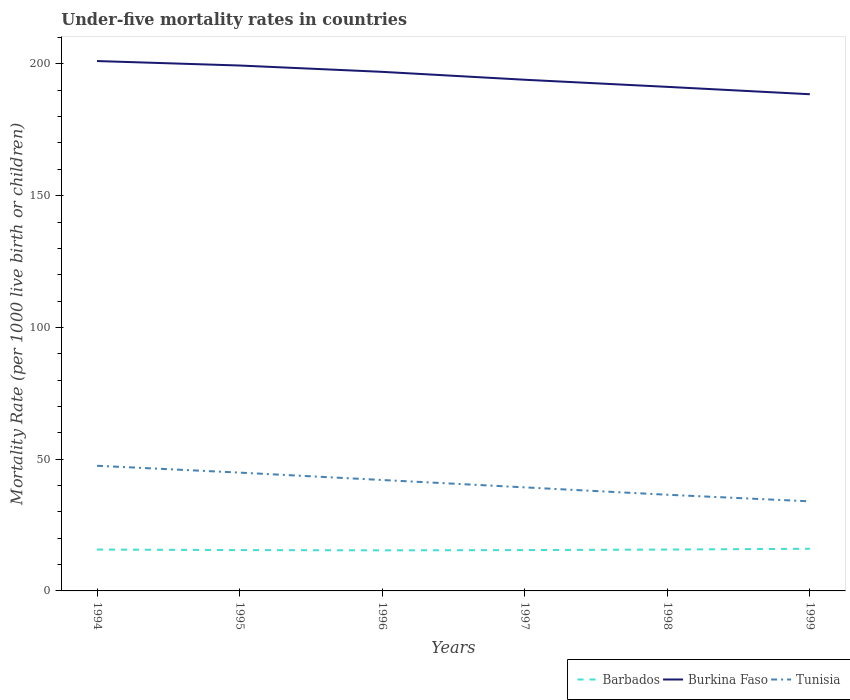How many different coloured lines are there?
Provide a short and direct response. 3. Across all years, what is the maximum under-five mortality rate in Burkina Faso?
Your answer should be very brief. 188.5. What is the total under-five mortality rate in Barbados in the graph?
Your answer should be compact. -0.6. What is the difference between the highest and the second highest under-five mortality rate in Barbados?
Your answer should be very brief. 0.6. What is the difference between the highest and the lowest under-five mortality rate in Barbados?
Offer a terse response. 3. How many lines are there?
Offer a very short reply. 3. What is the difference between two consecutive major ticks on the Y-axis?
Keep it short and to the point. 50. Does the graph contain any zero values?
Your response must be concise. No. Does the graph contain grids?
Keep it short and to the point. No. How many legend labels are there?
Your response must be concise. 3. What is the title of the graph?
Offer a terse response. Under-five mortality rates in countries. Does "East Asia (all income levels)" appear as one of the legend labels in the graph?
Offer a terse response. No. What is the label or title of the Y-axis?
Offer a terse response. Mortality Rate (per 1000 live birth or children). What is the Mortality Rate (per 1000 live birth or children) in Barbados in 1994?
Offer a terse response. 15.7. What is the Mortality Rate (per 1000 live birth or children) of Burkina Faso in 1994?
Provide a short and direct response. 201.1. What is the Mortality Rate (per 1000 live birth or children) in Tunisia in 1994?
Offer a terse response. 47.5. What is the Mortality Rate (per 1000 live birth or children) in Burkina Faso in 1995?
Your response must be concise. 199.4. What is the Mortality Rate (per 1000 live birth or children) in Tunisia in 1995?
Make the answer very short. 44.9. What is the Mortality Rate (per 1000 live birth or children) in Burkina Faso in 1996?
Provide a succinct answer. 197. What is the Mortality Rate (per 1000 live birth or children) in Tunisia in 1996?
Keep it short and to the point. 42.1. What is the Mortality Rate (per 1000 live birth or children) in Barbados in 1997?
Offer a very short reply. 15.5. What is the Mortality Rate (per 1000 live birth or children) in Burkina Faso in 1997?
Give a very brief answer. 194. What is the Mortality Rate (per 1000 live birth or children) in Tunisia in 1997?
Make the answer very short. 39.3. What is the Mortality Rate (per 1000 live birth or children) of Barbados in 1998?
Provide a succinct answer. 15.7. What is the Mortality Rate (per 1000 live birth or children) of Burkina Faso in 1998?
Provide a succinct answer. 191.3. What is the Mortality Rate (per 1000 live birth or children) in Tunisia in 1998?
Your answer should be compact. 36.5. What is the Mortality Rate (per 1000 live birth or children) in Barbados in 1999?
Give a very brief answer. 16. What is the Mortality Rate (per 1000 live birth or children) in Burkina Faso in 1999?
Ensure brevity in your answer.  188.5. Across all years, what is the maximum Mortality Rate (per 1000 live birth or children) of Barbados?
Offer a terse response. 16. Across all years, what is the maximum Mortality Rate (per 1000 live birth or children) of Burkina Faso?
Your answer should be compact. 201.1. Across all years, what is the maximum Mortality Rate (per 1000 live birth or children) in Tunisia?
Give a very brief answer. 47.5. Across all years, what is the minimum Mortality Rate (per 1000 live birth or children) in Burkina Faso?
Provide a succinct answer. 188.5. Across all years, what is the minimum Mortality Rate (per 1000 live birth or children) in Tunisia?
Offer a very short reply. 34. What is the total Mortality Rate (per 1000 live birth or children) of Barbados in the graph?
Your answer should be very brief. 93.8. What is the total Mortality Rate (per 1000 live birth or children) in Burkina Faso in the graph?
Offer a terse response. 1171.3. What is the total Mortality Rate (per 1000 live birth or children) of Tunisia in the graph?
Offer a terse response. 244.3. What is the difference between the Mortality Rate (per 1000 live birth or children) of Burkina Faso in 1994 and that in 1995?
Your response must be concise. 1.7. What is the difference between the Mortality Rate (per 1000 live birth or children) of Tunisia in 1994 and that in 1995?
Your response must be concise. 2.6. What is the difference between the Mortality Rate (per 1000 live birth or children) of Burkina Faso in 1994 and that in 1996?
Ensure brevity in your answer.  4.1. What is the difference between the Mortality Rate (per 1000 live birth or children) of Burkina Faso in 1994 and that in 1997?
Your answer should be compact. 7.1. What is the difference between the Mortality Rate (per 1000 live birth or children) of Tunisia in 1994 and that in 1997?
Your answer should be compact. 8.2. What is the difference between the Mortality Rate (per 1000 live birth or children) of Barbados in 1994 and that in 1998?
Keep it short and to the point. 0. What is the difference between the Mortality Rate (per 1000 live birth or children) of Burkina Faso in 1994 and that in 1998?
Your answer should be very brief. 9.8. What is the difference between the Mortality Rate (per 1000 live birth or children) in Burkina Faso in 1994 and that in 1999?
Offer a very short reply. 12.6. What is the difference between the Mortality Rate (per 1000 live birth or children) of Barbados in 1995 and that in 1996?
Your answer should be very brief. 0.1. What is the difference between the Mortality Rate (per 1000 live birth or children) of Tunisia in 1995 and that in 1996?
Offer a very short reply. 2.8. What is the difference between the Mortality Rate (per 1000 live birth or children) in Burkina Faso in 1995 and that in 1997?
Offer a terse response. 5.4. What is the difference between the Mortality Rate (per 1000 live birth or children) in Tunisia in 1995 and that in 1997?
Offer a terse response. 5.6. What is the difference between the Mortality Rate (per 1000 live birth or children) of Barbados in 1995 and that in 1998?
Keep it short and to the point. -0.2. What is the difference between the Mortality Rate (per 1000 live birth or children) of Burkina Faso in 1995 and that in 1999?
Make the answer very short. 10.9. What is the difference between the Mortality Rate (per 1000 live birth or children) in Tunisia in 1996 and that in 1997?
Offer a very short reply. 2.8. What is the difference between the Mortality Rate (per 1000 live birth or children) in Burkina Faso in 1996 and that in 1998?
Offer a terse response. 5.7. What is the difference between the Mortality Rate (per 1000 live birth or children) in Barbados in 1996 and that in 1999?
Make the answer very short. -0.6. What is the difference between the Mortality Rate (per 1000 live birth or children) in Tunisia in 1996 and that in 1999?
Your answer should be compact. 8.1. What is the difference between the Mortality Rate (per 1000 live birth or children) of Barbados in 1997 and that in 1998?
Your response must be concise. -0.2. What is the difference between the Mortality Rate (per 1000 live birth or children) in Burkina Faso in 1997 and that in 1998?
Offer a very short reply. 2.7. What is the difference between the Mortality Rate (per 1000 live birth or children) in Barbados in 1997 and that in 1999?
Offer a very short reply. -0.5. What is the difference between the Mortality Rate (per 1000 live birth or children) of Tunisia in 1997 and that in 1999?
Your answer should be compact. 5.3. What is the difference between the Mortality Rate (per 1000 live birth or children) of Barbados in 1994 and the Mortality Rate (per 1000 live birth or children) of Burkina Faso in 1995?
Provide a short and direct response. -183.7. What is the difference between the Mortality Rate (per 1000 live birth or children) in Barbados in 1994 and the Mortality Rate (per 1000 live birth or children) in Tunisia in 1995?
Keep it short and to the point. -29.2. What is the difference between the Mortality Rate (per 1000 live birth or children) of Burkina Faso in 1994 and the Mortality Rate (per 1000 live birth or children) of Tunisia in 1995?
Make the answer very short. 156.2. What is the difference between the Mortality Rate (per 1000 live birth or children) of Barbados in 1994 and the Mortality Rate (per 1000 live birth or children) of Burkina Faso in 1996?
Offer a terse response. -181.3. What is the difference between the Mortality Rate (per 1000 live birth or children) in Barbados in 1994 and the Mortality Rate (per 1000 live birth or children) in Tunisia in 1996?
Provide a short and direct response. -26.4. What is the difference between the Mortality Rate (per 1000 live birth or children) in Burkina Faso in 1994 and the Mortality Rate (per 1000 live birth or children) in Tunisia in 1996?
Provide a succinct answer. 159. What is the difference between the Mortality Rate (per 1000 live birth or children) in Barbados in 1994 and the Mortality Rate (per 1000 live birth or children) in Burkina Faso in 1997?
Offer a very short reply. -178.3. What is the difference between the Mortality Rate (per 1000 live birth or children) in Barbados in 1994 and the Mortality Rate (per 1000 live birth or children) in Tunisia in 1997?
Your answer should be very brief. -23.6. What is the difference between the Mortality Rate (per 1000 live birth or children) of Burkina Faso in 1994 and the Mortality Rate (per 1000 live birth or children) of Tunisia in 1997?
Make the answer very short. 161.8. What is the difference between the Mortality Rate (per 1000 live birth or children) of Barbados in 1994 and the Mortality Rate (per 1000 live birth or children) of Burkina Faso in 1998?
Offer a terse response. -175.6. What is the difference between the Mortality Rate (per 1000 live birth or children) in Barbados in 1994 and the Mortality Rate (per 1000 live birth or children) in Tunisia in 1998?
Your response must be concise. -20.8. What is the difference between the Mortality Rate (per 1000 live birth or children) in Burkina Faso in 1994 and the Mortality Rate (per 1000 live birth or children) in Tunisia in 1998?
Your response must be concise. 164.6. What is the difference between the Mortality Rate (per 1000 live birth or children) of Barbados in 1994 and the Mortality Rate (per 1000 live birth or children) of Burkina Faso in 1999?
Give a very brief answer. -172.8. What is the difference between the Mortality Rate (per 1000 live birth or children) of Barbados in 1994 and the Mortality Rate (per 1000 live birth or children) of Tunisia in 1999?
Your response must be concise. -18.3. What is the difference between the Mortality Rate (per 1000 live birth or children) of Burkina Faso in 1994 and the Mortality Rate (per 1000 live birth or children) of Tunisia in 1999?
Provide a short and direct response. 167.1. What is the difference between the Mortality Rate (per 1000 live birth or children) of Barbados in 1995 and the Mortality Rate (per 1000 live birth or children) of Burkina Faso in 1996?
Your response must be concise. -181.5. What is the difference between the Mortality Rate (per 1000 live birth or children) of Barbados in 1995 and the Mortality Rate (per 1000 live birth or children) of Tunisia in 1996?
Make the answer very short. -26.6. What is the difference between the Mortality Rate (per 1000 live birth or children) of Burkina Faso in 1995 and the Mortality Rate (per 1000 live birth or children) of Tunisia in 1996?
Your answer should be very brief. 157.3. What is the difference between the Mortality Rate (per 1000 live birth or children) of Barbados in 1995 and the Mortality Rate (per 1000 live birth or children) of Burkina Faso in 1997?
Your answer should be compact. -178.5. What is the difference between the Mortality Rate (per 1000 live birth or children) in Barbados in 1995 and the Mortality Rate (per 1000 live birth or children) in Tunisia in 1997?
Keep it short and to the point. -23.8. What is the difference between the Mortality Rate (per 1000 live birth or children) in Burkina Faso in 1995 and the Mortality Rate (per 1000 live birth or children) in Tunisia in 1997?
Offer a terse response. 160.1. What is the difference between the Mortality Rate (per 1000 live birth or children) of Barbados in 1995 and the Mortality Rate (per 1000 live birth or children) of Burkina Faso in 1998?
Your answer should be very brief. -175.8. What is the difference between the Mortality Rate (per 1000 live birth or children) of Barbados in 1995 and the Mortality Rate (per 1000 live birth or children) of Tunisia in 1998?
Offer a very short reply. -21. What is the difference between the Mortality Rate (per 1000 live birth or children) in Burkina Faso in 1995 and the Mortality Rate (per 1000 live birth or children) in Tunisia in 1998?
Your answer should be compact. 162.9. What is the difference between the Mortality Rate (per 1000 live birth or children) in Barbados in 1995 and the Mortality Rate (per 1000 live birth or children) in Burkina Faso in 1999?
Ensure brevity in your answer.  -173. What is the difference between the Mortality Rate (per 1000 live birth or children) of Barbados in 1995 and the Mortality Rate (per 1000 live birth or children) of Tunisia in 1999?
Give a very brief answer. -18.5. What is the difference between the Mortality Rate (per 1000 live birth or children) in Burkina Faso in 1995 and the Mortality Rate (per 1000 live birth or children) in Tunisia in 1999?
Your answer should be compact. 165.4. What is the difference between the Mortality Rate (per 1000 live birth or children) of Barbados in 1996 and the Mortality Rate (per 1000 live birth or children) of Burkina Faso in 1997?
Your response must be concise. -178.6. What is the difference between the Mortality Rate (per 1000 live birth or children) of Barbados in 1996 and the Mortality Rate (per 1000 live birth or children) of Tunisia in 1997?
Offer a very short reply. -23.9. What is the difference between the Mortality Rate (per 1000 live birth or children) in Burkina Faso in 1996 and the Mortality Rate (per 1000 live birth or children) in Tunisia in 1997?
Make the answer very short. 157.7. What is the difference between the Mortality Rate (per 1000 live birth or children) in Barbados in 1996 and the Mortality Rate (per 1000 live birth or children) in Burkina Faso in 1998?
Offer a terse response. -175.9. What is the difference between the Mortality Rate (per 1000 live birth or children) of Barbados in 1996 and the Mortality Rate (per 1000 live birth or children) of Tunisia in 1998?
Your answer should be compact. -21.1. What is the difference between the Mortality Rate (per 1000 live birth or children) in Burkina Faso in 1996 and the Mortality Rate (per 1000 live birth or children) in Tunisia in 1998?
Make the answer very short. 160.5. What is the difference between the Mortality Rate (per 1000 live birth or children) of Barbados in 1996 and the Mortality Rate (per 1000 live birth or children) of Burkina Faso in 1999?
Your response must be concise. -173.1. What is the difference between the Mortality Rate (per 1000 live birth or children) in Barbados in 1996 and the Mortality Rate (per 1000 live birth or children) in Tunisia in 1999?
Provide a succinct answer. -18.6. What is the difference between the Mortality Rate (per 1000 live birth or children) in Burkina Faso in 1996 and the Mortality Rate (per 1000 live birth or children) in Tunisia in 1999?
Keep it short and to the point. 163. What is the difference between the Mortality Rate (per 1000 live birth or children) in Barbados in 1997 and the Mortality Rate (per 1000 live birth or children) in Burkina Faso in 1998?
Give a very brief answer. -175.8. What is the difference between the Mortality Rate (per 1000 live birth or children) of Burkina Faso in 1997 and the Mortality Rate (per 1000 live birth or children) of Tunisia in 1998?
Ensure brevity in your answer.  157.5. What is the difference between the Mortality Rate (per 1000 live birth or children) of Barbados in 1997 and the Mortality Rate (per 1000 live birth or children) of Burkina Faso in 1999?
Your response must be concise. -173. What is the difference between the Mortality Rate (per 1000 live birth or children) in Barbados in 1997 and the Mortality Rate (per 1000 live birth or children) in Tunisia in 1999?
Your response must be concise. -18.5. What is the difference between the Mortality Rate (per 1000 live birth or children) of Burkina Faso in 1997 and the Mortality Rate (per 1000 live birth or children) of Tunisia in 1999?
Ensure brevity in your answer.  160. What is the difference between the Mortality Rate (per 1000 live birth or children) of Barbados in 1998 and the Mortality Rate (per 1000 live birth or children) of Burkina Faso in 1999?
Offer a terse response. -172.8. What is the difference between the Mortality Rate (per 1000 live birth or children) in Barbados in 1998 and the Mortality Rate (per 1000 live birth or children) in Tunisia in 1999?
Your answer should be very brief. -18.3. What is the difference between the Mortality Rate (per 1000 live birth or children) of Burkina Faso in 1998 and the Mortality Rate (per 1000 live birth or children) of Tunisia in 1999?
Offer a very short reply. 157.3. What is the average Mortality Rate (per 1000 live birth or children) in Barbados per year?
Your answer should be compact. 15.63. What is the average Mortality Rate (per 1000 live birth or children) of Burkina Faso per year?
Make the answer very short. 195.22. What is the average Mortality Rate (per 1000 live birth or children) of Tunisia per year?
Keep it short and to the point. 40.72. In the year 1994, what is the difference between the Mortality Rate (per 1000 live birth or children) in Barbados and Mortality Rate (per 1000 live birth or children) in Burkina Faso?
Keep it short and to the point. -185.4. In the year 1994, what is the difference between the Mortality Rate (per 1000 live birth or children) of Barbados and Mortality Rate (per 1000 live birth or children) of Tunisia?
Your answer should be very brief. -31.8. In the year 1994, what is the difference between the Mortality Rate (per 1000 live birth or children) in Burkina Faso and Mortality Rate (per 1000 live birth or children) in Tunisia?
Offer a terse response. 153.6. In the year 1995, what is the difference between the Mortality Rate (per 1000 live birth or children) of Barbados and Mortality Rate (per 1000 live birth or children) of Burkina Faso?
Provide a short and direct response. -183.9. In the year 1995, what is the difference between the Mortality Rate (per 1000 live birth or children) of Barbados and Mortality Rate (per 1000 live birth or children) of Tunisia?
Your answer should be compact. -29.4. In the year 1995, what is the difference between the Mortality Rate (per 1000 live birth or children) in Burkina Faso and Mortality Rate (per 1000 live birth or children) in Tunisia?
Provide a short and direct response. 154.5. In the year 1996, what is the difference between the Mortality Rate (per 1000 live birth or children) in Barbados and Mortality Rate (per 1000 live birth or children) in Burkina Faso?
Give a very brief answer. -181.6. In the year 1996, what is the difference between the Mortality Rate (per 1000 live birth or children) in Barbados and Mortality Rate (per 1000 live birth or children) in Tunisia?
Make the answer very short. -26.7. In the year 1996, what is the difference between the Mortality Rate (per 1000 live birth or children) in Burkina Faso and Mortality Rate (per 1000 live birth or children) in Tunisia?
Ensure brevity in your answer.  154.9. In the year 1997, what is the difference between the Mortality Rate (per 1000 live birth or children) in Barbados and Mortality Rate (per 1000 live birth or children) in Burkina Faso?
Make the answer very short. -178.5. In the year 1997, what is the difference between the Mortality Rate (per 1000 live birth or children) of Barbados and Mortality Rate (per 1000 live birth or children) of Tunisia?
Give a very brief answer. -23.8. In the year 1997, what is the difference between the Mortality Rate (per 1000 live birth or children) in Burkina Faso and Mortality Rate (per 1000 live birth or children) in Tunisia?
Your answer should be very brief. 154.7. In the year 1998, what is the difference between the Mortality Rate (per 1000 live birth or children) in Barbados and Mortality Rate (per 1000 live birth or children) in Burkina Faso?
Your answer should be compact. -175.6. In the year 1998, what is the difference between the Mortality Rate (per 1000 live birth or children) of Barbados and Mortality Rate (per 1000 live birth or children) of Tunisia?
Offer a very short reply. -20.8. In the year 1998, what is the difference between the Mortality Rate (per 1000 live birth or children) of Burkina Faso and Mortality Rate (per 1000 live birth or children) of Tunisia?
Offer a terse response. 154.8. In the year 1999, what is the difference between the Mortality Rate (per 1000 live birth or children) of Barbados and Mortality Rate (per 1000 live birth or children) of Burkina Faso?
Your answer should be compact. -172.5. In the year 1999, what is the difference between the Mortality Rate (per 1000 live birth or children) of Barbados and Mortality Rate (per 1000 live birth or children) of Tunisia?
Provide a succinct answer. -18. In the year 1999, what is the difference between the Mortality Rate (per 1000 live birth or children) of Burkina Faso and Mortality Rate (per 1000 live birth or children) of Tunisia?
Keep it short and to the point. 154.5. What is the ratio of the Mortality Rate (per 1000 live birth or children) in Barbados in 1994 to that in 1995?
Keep it short and to the point. 1.01. What is the ratio of the Mortality Rate (per 1000 live birth or children) in Burkina Faso in 1994 to that in 1995?
Offer a very short reply. 1.01. What is the ratio of the Mortality Rate (per 1000 live birth or children) in Tunisia in 1994 to that in 1995?
Your response must be concise. 1.06. What is the ratio of the Mortality Rate (per 1000 live birth or children) of Barbados in 1994 to that in 1996?
Ensure brevity in your answer.  1.02. What is the ratio of the Mortality Rate (per 1000 live birth or children) in Burkina Faso in 1994 to that in 1996?
Provide a short and direct response. 1.02. What is the ratio of the Mortality Rate (per 1000 live birth or children) in Tunisia in 1994 to that in 1996?
Your answer should be compact. 1.13. What is the ratio of the Mortality Rate (per 1000 live birth or children) in Barbados in 1994 to that in 1997?
Make the answer very short. 1.01. What is the ratio of the Mortality Rate (per 1000 live birth or children) of Burkina Faso in 1994 to that in 1997?
Provide a succinct answer. 1.04. What is the ratio of the Mortality Rate (per 1000 live birth or children) of Tunisia in 1994 to that in 1997?
Provide a succinct answer. 1.21. What is the ratio of the Mortality Rate (per 1000 live birth or children) in Barbados in 1994 to that in 1998?
Make the answer very short. 1. What is the ratio of the Mortality Rate (per 1000 live birth or children) in Burkina Faso in 1994 to that in 1998?
Your answer should be very brief. 1.05. What is the ratio of the Mortality Rate (per 1000 live birth or children) of Tunisia in 1994 to that in 1998?
Provide a short and direct response. 1.3. What is the ratio of the Mortality Rate (per 1000 live birth or children) of Barbados in 1994 to that in 1999?
Provide a succinct answer. 0.98. What is the ratio of the Mortality Rate (per 1000 live birth or children) of Burkina Faso in 1994 to that in 1999?
Offer a very short reply. 1.07. What is the ratio of the Mortality Rate (per 1000 live birth or children) in Tunisia in 1994 to that in 1999?
Provide a succinct answer. 1.4. What is the ratio of the Mortality Rate (per 1000 live birth or children) of Burkina Faso in 1995 to that in 1996?
Give a very brief answer. 1.01. What is the ratio of the Mortality Rate (per 1000 live birth or children) in Tunisia in 1995 to that in 1996?
Offer a very short reply. 1.07. What is the ratio of the Mortality Rate (per 1000 live birth or children) of Barbados in 1995 to that in 1997?
Offer a terse response. 1. What is the ratio of the Mortality Rate (per 1000 live birth or children) in Burkina Faso in 1995 to that in 1997?
Provide a succinct answer. 1.03. What is the ratio of the Mortality Rate (per 1000 live birth or children) in Tunisia in 1995 to that in 1997?
Offer a very short reply. 1.14. What is the ratio of the Mortality Rate (per 1000 live birth or children) in Barbados in 1995 to that in 1998?
Offer a terse response. 0.99. What is the ratio of the Mortality Rate (per 1000 live birth or children) in Burkina Faso in 1995 to that in 1998?
Provide a succinct answer. 1.04. What is the ratio of the Mortality Rate (per 1000 live birth or children) in Tunisia in 1995 to that in 1998?
Your answer should be compact. 1.23. What is the ratio of the Mortality Rate (per 1000 live birth or children) of Barbados in 1995 to that in 1999?
Provide a short and direct response. 0.97. What is the ratio of the Mortality Rate (per 1000 live birth or children) of Burkina Faso in 1995 to that in 1999?
Ensure brevity in your answer.  1.06. What is the ratio of the Mortality Rate (per 1000 live birth or children) in Tunisia in 1995 to that in 1999?
Your response must be concise. 1.32. What is the ratio of the Mortality Rate (per 1000 live birth or children) of Burkina Faso in 1996 to that in 1997?
Make the answer very short. 1.02. What is the ratio of the Mortality Rate (per 1000 live birth or children) in Tunisia in 1996 to that in 1997?
Your answer should be compact. 1.07. What is the ratio of the Mortality Rate (per 1000 live birth or children) of Barbados in 1996 to that in 1998?
Your response must be concise. 0.98. What is the ratio of the Mortality Rate (per 1000 live birth or children) in Burkina Faso in 1996 to that in 1998?
Your response must be concise. 1.03. What is the ratio of the Mortality Rate (per 1000 live birth or children) in Tunisia in 1996 to that in 1998?
Make the answer very short. 1.15. What is the ratio of the Mortality Rate (per 1000 live birth or children) of Barbados in 1996 to that in 1999?
Your answer should be compact. 0.96. What is the ratio of the Mortality Rate (per 1000 live birth or children) in Burkina Faso in 1996 to that in 1999?
Offer a terse response. 1.05. What is the ratio of the Mortality Rate (per 1000 live birth or children) of Tunisia in 1996 to that in 1999?
Your response must be concise. 1.24. What is the ratio of the Mortality Rate (per 1000 live birth or children) of Barbados in 1997 to that in 1998?
Your answer should be very brief. 0.99. What is the ratio of the Mortality Rate (per 1000 live birth or children) of Burkina Faso in 1997 to that in 1998?
Offer a terse response. 1.01. What is the ratio of the Mortality Rate (per 1000 live birth or children) in Tunisia in 1997 to that in 1998?
Your answer should be compact. 1.08. What is the ratio of the Mortality Rate (per 1000 live birth or children) of Barbados in 1997 to that in 1999?
Make the answer very short. 0.97. What is the ratio of the Mortality Rate (per 1000 live birth or children) in Burkina Faso in 1997 to that in 1999?
Provide a short and direct response. 1.03. What is the ratio of the Mortality Rate (per 1000 live birth or children) of Tunisia in 1997 to that in 1999?
Ensure brevity in your answer.  1.16. What is the ratio of the Mortality Rate (per 1000 live birth or children) of Barbados in 1998 to that in 1999?
Give a very brief answer. 0.98. What is the ratio of the Mortality Rate (per 1000 live birth or children) in Burkina Faso in 1998 to that in 1999?
Give a very brief answer. 1.01. What is the ratio of the Mortality Rate (per 1000 live birth or children) in Tunisia in 1998 to that in 1999?
Keep it short and to the point. 1.07. What is the difference between the highest and the second highest Mortality Rate (per 1000 live birth or children) of Tunisia?
Provide a succinct answer. 2.6. What is the difference between the highest and the lowest Mortality Rate (per 1000 live birth or children) of Barbados?
Provide a short and direct response. 0.6. 